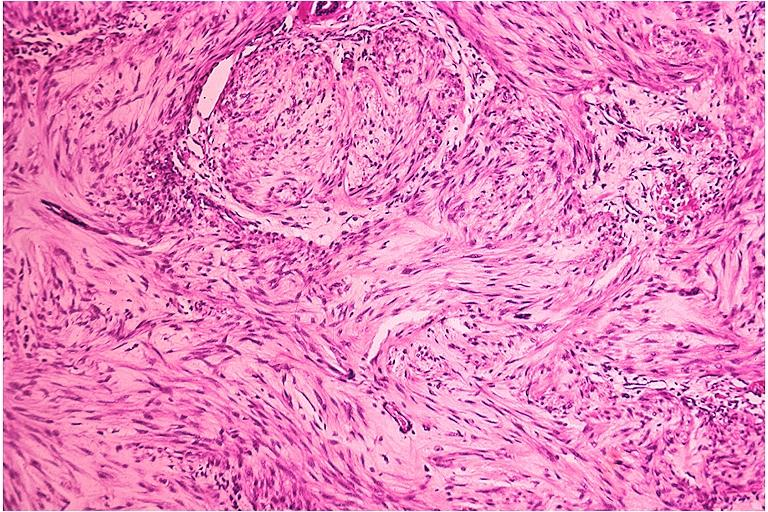does mixed mesodermal tumor show neurofibroma?
Answer the question using a single word or phrase. No 